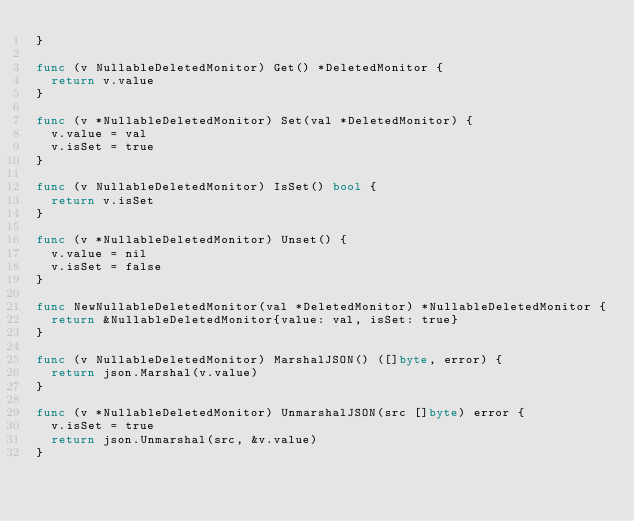Convert code to text. <code><loc_0><loc_0><loc_500><loc_500><_Go_>}

func (v NullableDeletedMonitor) Get() *DeletedMonitor {
	return v.value
}

func (v *NullableDeletedMonitor) Set(val *DeletedMonitor) {
	v.value = val
	v.isSet = true
}

func (v NullableDeletedMonitor) IsSet() bool {
	return v.isSet
}

func (v *NullableDeletedMonitor) Unset() {
	v.value = nil
	v.isSet = false
}

func NewNullableDeletedMonitor(val *DeletedMonitor) *NullableDeletedMonitor {
	return &NullableDeletedMonitor{value: val, isSet: true}
}

func (v NullableDeletedMonitor) MarshalJSON() ([]byte, error) {
	return json.Marshal(v.value)
}

func (v *NullableDeletedMonitor) UnmarshalJSON(src []byte) error {
	v.isSet = true
	return json.Unmarshal(src, &v.value)
}
</code> 